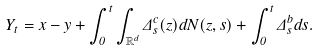<formula> <loc_0><loc_0><loc_500><loc_500>Y _ { t } = x - y + \int _ { 0 } ^ { t } \int _ { \mathbb { R } ^ { d } } \Delta _ { s } ^ { c } ( z ) d N ( z , s ) + \int _ { 0 } ^ { t } \Delta _ { s } ^ { b } d s .</formula> 